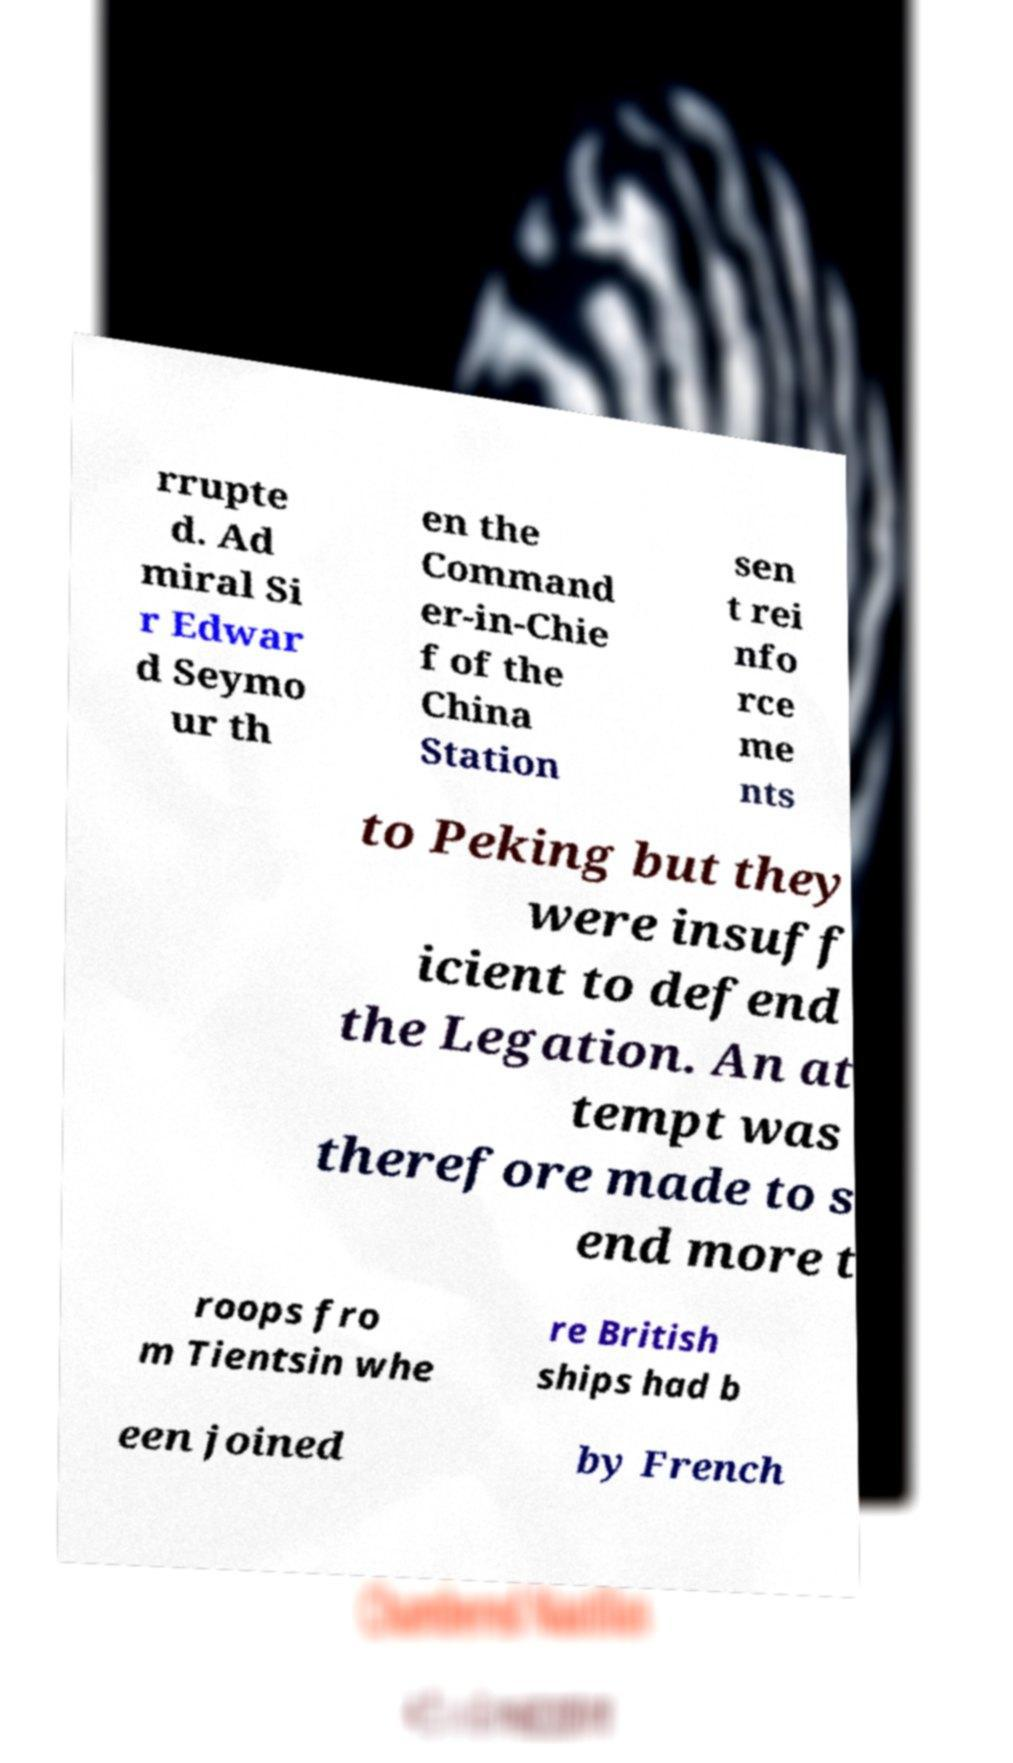I need the written content from this picture converted into text. Can you do that? rrupte d. Ad miral Si r Edwar d Seymo ur th en the Command er-in-Chie f of the China Station sen t rei nfo rce me nts to Peking but they were insuff icient to defend the Legation. An at tempt was therefore made to s end more t roops fro m Tientsin whe re British ships had b een joined by French 